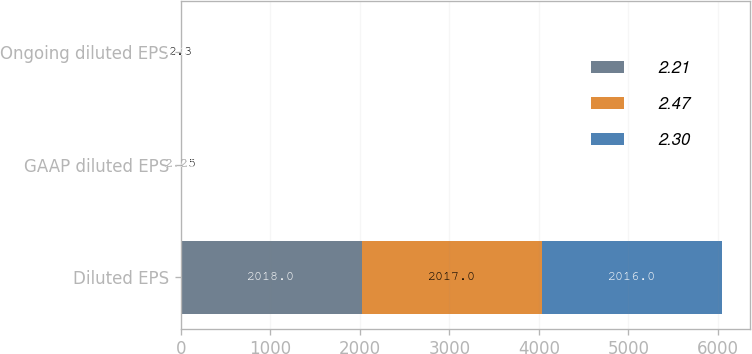Convert chart to OTSL. <chart><loc_0><loc_0><loc_500><loc_500><stacked_bar_chart><ecel><fcel>Diluted EPS<fcel>GAAP diluted EPS<fcel>Ongoing diluted EPS<nl><fcel>2.21<fcel>2018<fcel>2.47<fcel>2.47<nl><fcel>2.47<fcel>2017<fcel>2.25<fcel>2.3<nl><fcel>2.3<fcel>2016<fcel>2.21<fcel>2.21<nl></chart> 